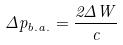Convert formula to latex. <formula><loc_0><loc_0><loc_500><loc_500>\Delta p _ { b . a . } = \frac { 2 \Delta W } { c }</formula> 